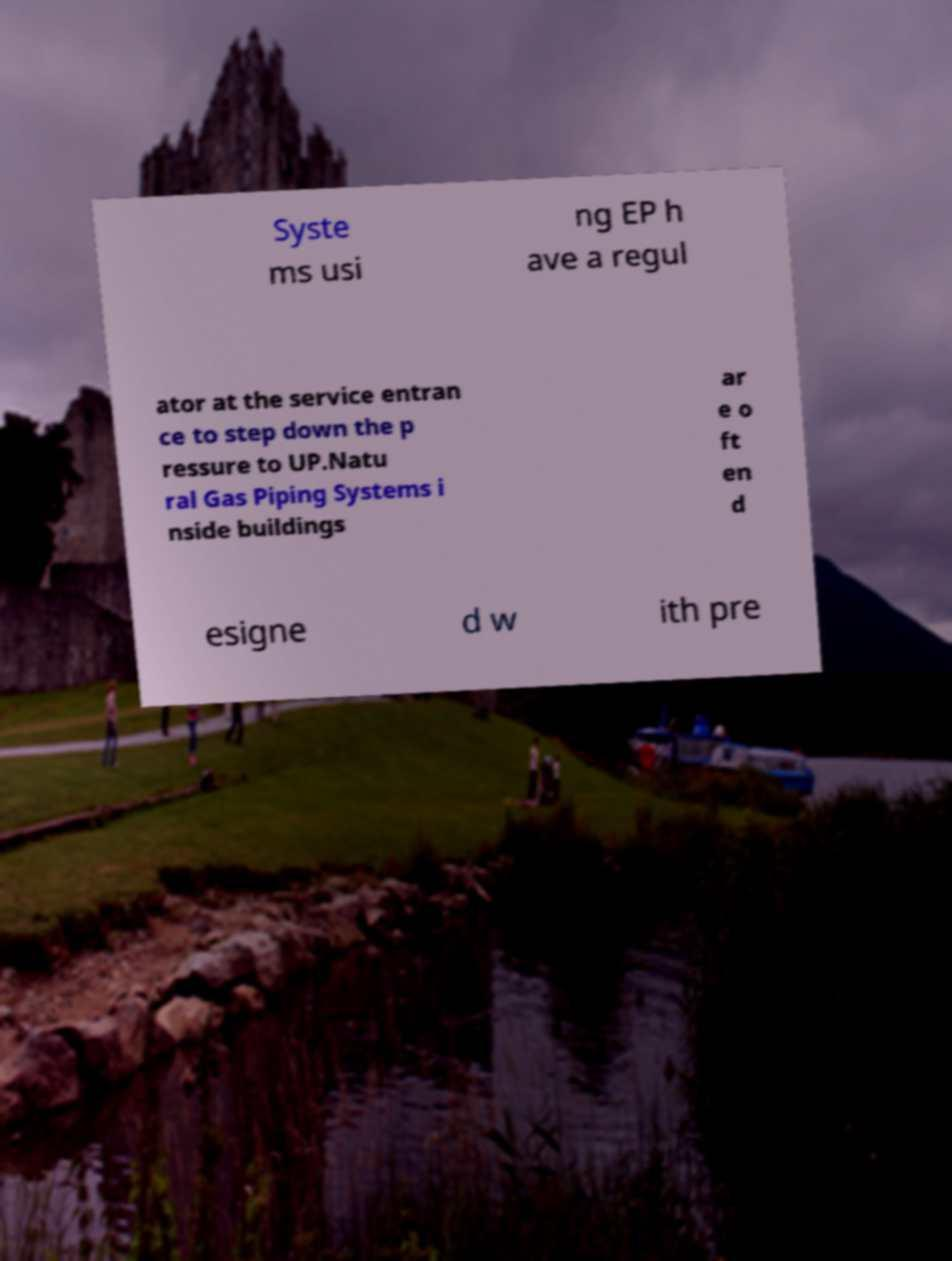Please identify and transcribe the text found in this image. Syste ms usi ng EP h ave a regul ator at the service entran ce to step down the p ressure to UP.Natu ral Gas Piping Systems i nside buildings ar e o ft en d esigne d w ith pre 